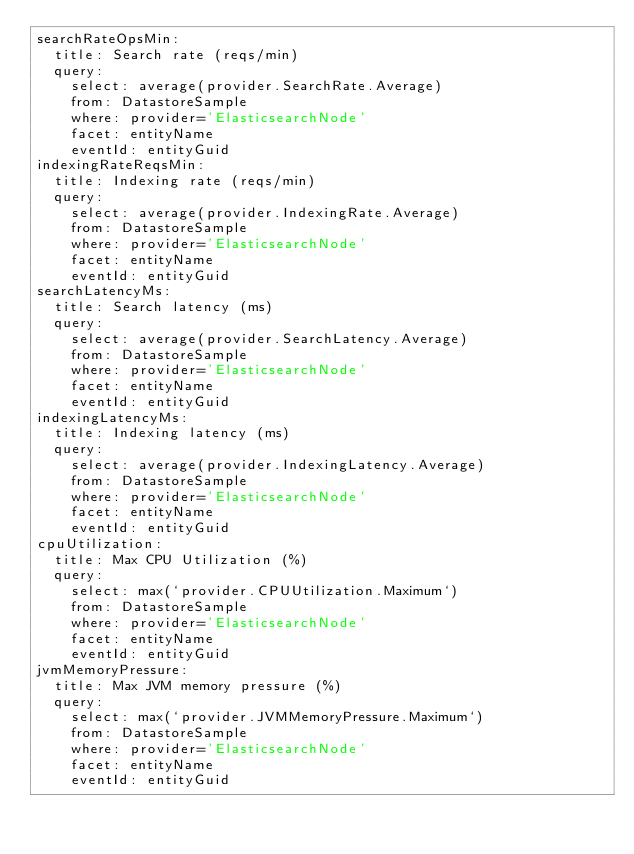<code> <loc_0><loc_0><loc_500><loc_500><_YAML_>searchRateOpsMin:
  title: Search rate (reqs/min)
  query:
    select: average(provider.SearchRate.Average)
    from: DatastoreSample
    where: provider='ElasticsearchNode'
    facet: entityName
    eventId: entityGuid
indexingRateReqsMin:
  title: Indexing rate (reqs/min)
  query:
    select: average(provider.IndexingRate.Average)
    from: DatastoreSample
    where: provider='ElasticsearchNode'
    facet: entityName
    eventId: entityGuid
searchLatencyMs:
  title: Search latency (ms)
  query:
    select: average(provider.SearchLatency.Average)
    from: DatastoreSample
    where: provider='ElasticsearchNode'
    facet: entityName
    eventId: entityGuid
indexingLatencyMs:
  title: Indexing latency (ms)
  query:
    select: average(provider.IndexingLatency.Average)
    from: DatastoreSample
    where: provider='ElasticsearchNode'
    facet: entityName
    eventId: entityGuid
cpuUtilization:
  title: Max CPU Utilization (%)
  query:
    select: max(`provider.CPUUtilization.Maximum`)
    from: DatastoreSample
    where: provider='ElasticsearchNode'
    facet: entityName
    eventId: entityGuid
jvmMemoryPressure:
  title: Max JVM memory pressure (%)
  query:
    select: max(`provider.JVMMemoryPressure.Maximum`)
    from: DatastoreSample
    where: provider='ElasticsearchNode'
    facet: entityName
    eventId: entityGuid
</code> 